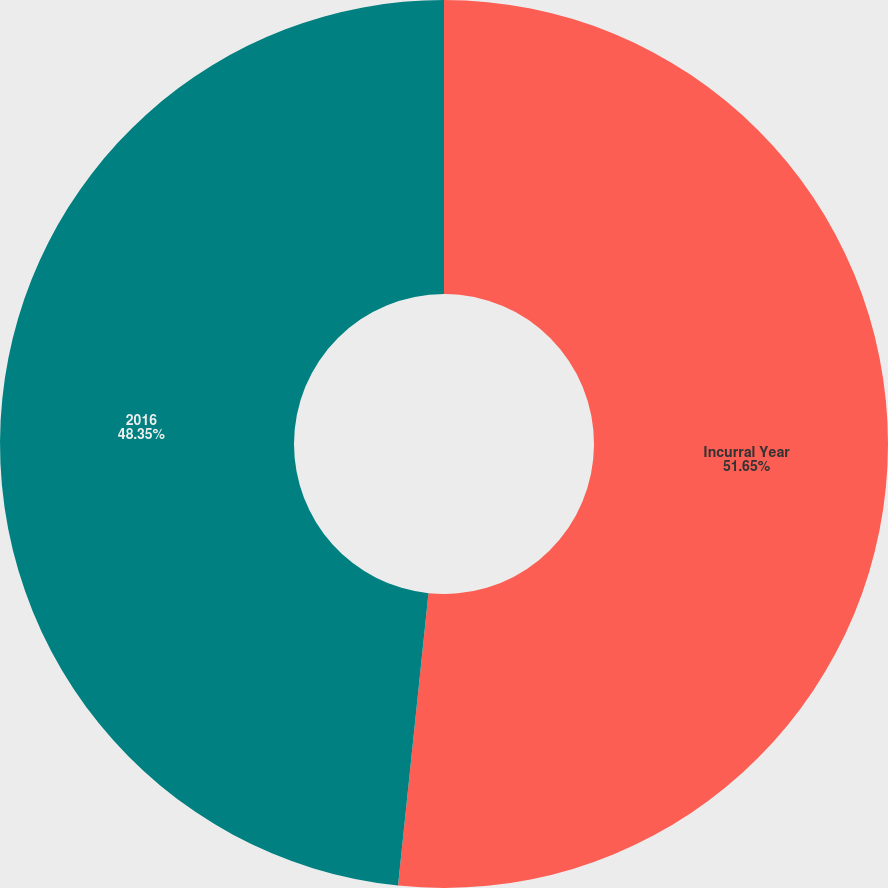Convert chart. <chart><loc_0><loc_0><loc_500><loc_500><pie_chart><fcel>Incurral Year<fcel>2016<nl><fcel>51.65%<fcel>48.35%<nl></chart> 